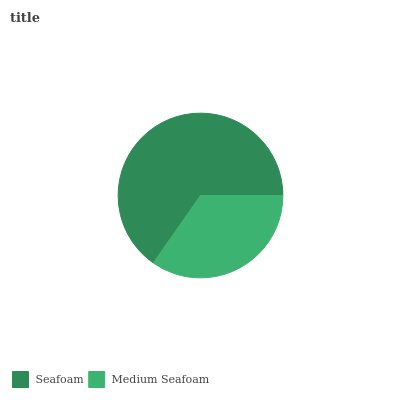Is Medium Seafoam the minimum?
Answer yes or no. Yes. Is Seafoam the maximum?
Answer yes or no. Yes. Is Medium Seafoam the maximum?
Answer yes or no. No. Is Seafoam greater than Medium Seafoam?
Answer yes or no. Yes. Is Medium Seafoam less than Seafoam?
Answer yes or no. Yes. Is Medium Seafoam greater than Seafoam?
Answer yes or no. No. Is Seafoam less than Medium Seafoam?
Answer yes or no. No. Is Seafoam the high median?
Answer yes or no. Yes. Is Medium Seafoam the low median?
Answer yes or no. Yes. Is Medium Seafoam the high median?
Answer yes or no. No. Is Seafoam the low median?
Answer yes or no. No. 